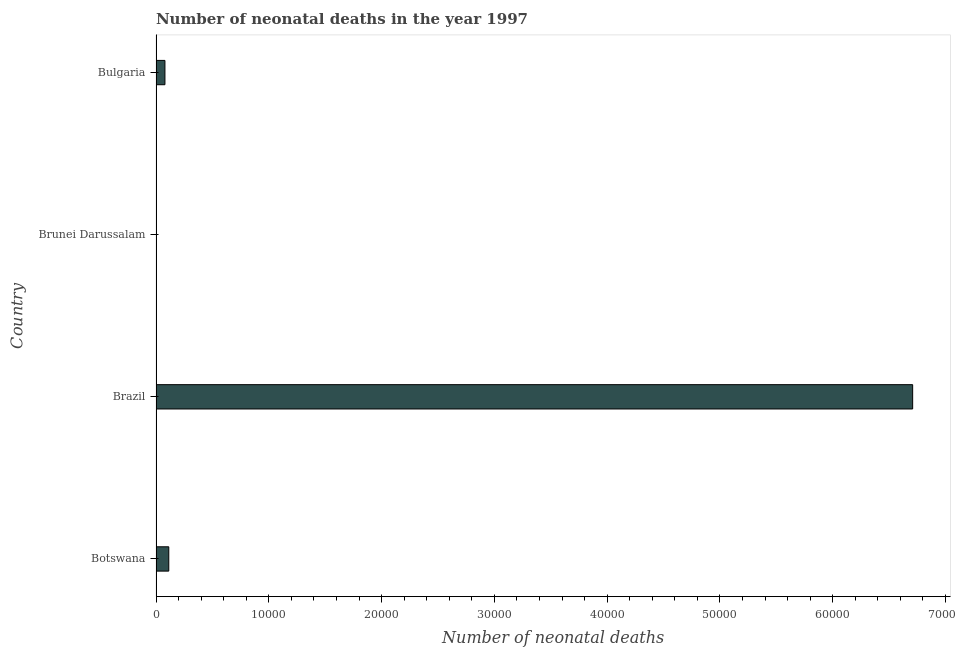What is the title of the graph?
Give a very brief answer. Number of neonatal deaths in the year 1997. What is the label or title of the X-axis?
Your answer should be compact. Number of neonatal deaths. What is the label or title of the Y-axis?
Make the answer very short. Country. Across all countries, what is the maximum number of neonatal deaths?
Your response must be concise. 6.71e+04. In which country was the number of neonatal deaths minimum?
Offer a very short reply. Brunei Darussalam. What is the sum of the number of neonatal deaths?
Keep it short and to the point. 6.91e+04. What is the difference between the number of neonatal deaths in Brunei Darussalam and Bulgaria?
Your answer should be compact. -752. What is the average number of neonatal deaths per country?
Ensure brevity in your answer.  1.73e+04. What is the median number of neonatal deaths?
Give a very brief answer. 961. In how many countries, is the number of neonatal deaths greater than 34000 ?
Your answer should be compact. 1. What is the ratio of the number of neonatal deaths in Botswana to that in Brunei Darussalam?
Your response must be concise. 29.79. Is the difference between the number of neonatal deaths in Botswana and Brunei Darussalam greater than the difference between any two countries?
Make the answer very short. No. What is the difference between the highest and the second highest number of neonatal deaths?
Provide a succinct answer. 6.60e+04. What is the difference between the highest and the lowest number of neonatal deaths?
Offer a terse response. 6.71e+04. How many bars are there?
Your answer should be very brief. 4. What is the difference between two consecutive major ticks on the X-axis?
Keep it short and to the point. 10000. Are the values on the major ticks of X-axis written in scientific E-notation?
Offer a terse response. No. What is the Number of neonatal deaths in Botswana?
Your response must be concise. 1132. What is the Number of neonatal deaths of Brazil?
Provide a succinct answer. 6.71e+04. What is the Number of neonatal deaths of Brunei Darussalam?
Your answer should be compact. 38. What is the Number of neonatal deaths of Bulgaria?
Your response must be concise. 790. What is the difference between the Number of neonatal deaths in Botswana and Brazil?
Your answer should be compact. -6.60e+04. What is the difference between the Number of neonatal deaths in Botswana and Brunei Darussalam?
Make the answer very short. 1094. What is the difference between the Number of neonatal deaths in Botswana and Bulgaria?
Ensure brevity in your answer.  342. What is the difference between the Number of neonatal deaths in Brazil and Brunei Darussalam?
Offer a very short reply. 6.71e+04. What is the difference between the Number of neonatal deaths in Brazil and Bulgaria?
Make the answer very short. 6.63e+04. What is the difference between the Number of neonatal deaths in Brunei Darussalam and Bulgaria?
Provide a succinct answer. -752. What is the ratio of the Number of neonatal deaths in Botswana to that in Brazil?
Ensure brevity in your answer.  0.02. What is the ratio of the Number of neonatal deaths in Botswana to that in Brunei Darussalam?
Your answer should be very brief. 29.79. What is the ratio of the Number of neonatal deaths in Botswana to that in Bulgaria?
Offer a terse response. 1.43. What is the ratio of the Number of neonatal deaths in Brazil to that in Brunei Darussalam?
Make the answer very short. 1765.58. What is the ratio of the Number of neonatal deaths in Brazil to that in Bulgaria?
Provide a short and direct response. 84.93. What is the ratio of the Number of neonatal deaths in Brunei Darussalam to that in Bulgaria?
Give a very brief answer. 0.05. 